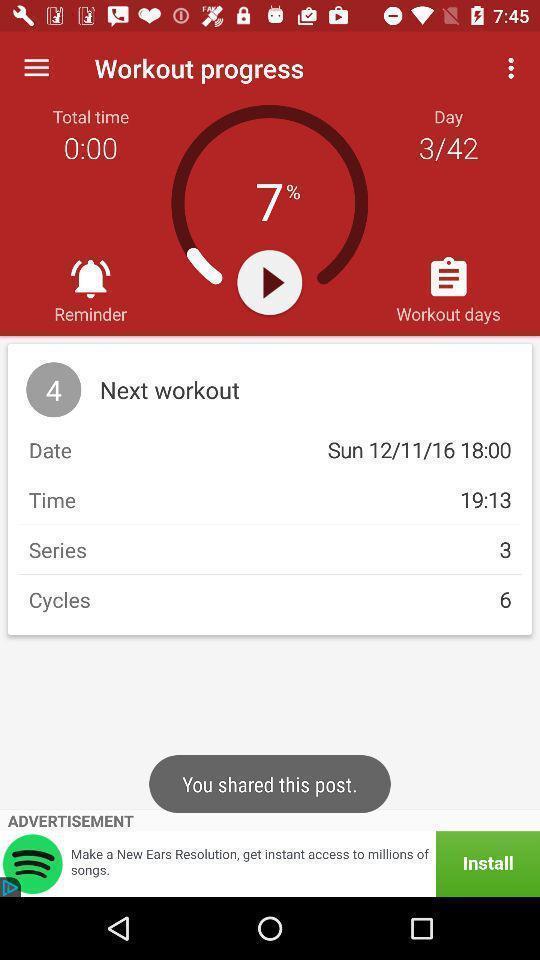Describe the key features of this screenshot. Workout schedule page of a fitness app. 